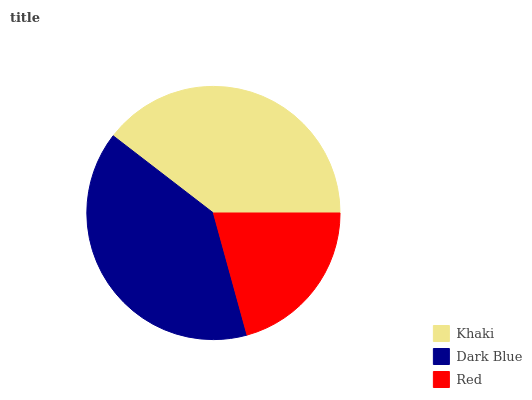Is Red the minimum?
Answer yes or no. Yes. Is Dark Blue the maximum?
Answer yes or no. Yes. Is Dark Blue the minimum?
Answer yes or no. No. Is Red the maximum?
Answer yes or no. No. Is Dark Blue greater than Red?
Answer yes or no. Yes. Is Red less than Dark Blue?
Answer yes or no. Yes. Is Red greater than Dark Blue?
Answer yes or no. No. Is Dark Blue less than Red?
Answer yes or no. No. Is Khaki the high median?
Answer yes or no. Yes. Is Khaki the low median?
Answer yes or no. Yes. Is Dark Blue the high median?
Answer yes or no. No. Is Red the low median?
Answer yes or no. No. 